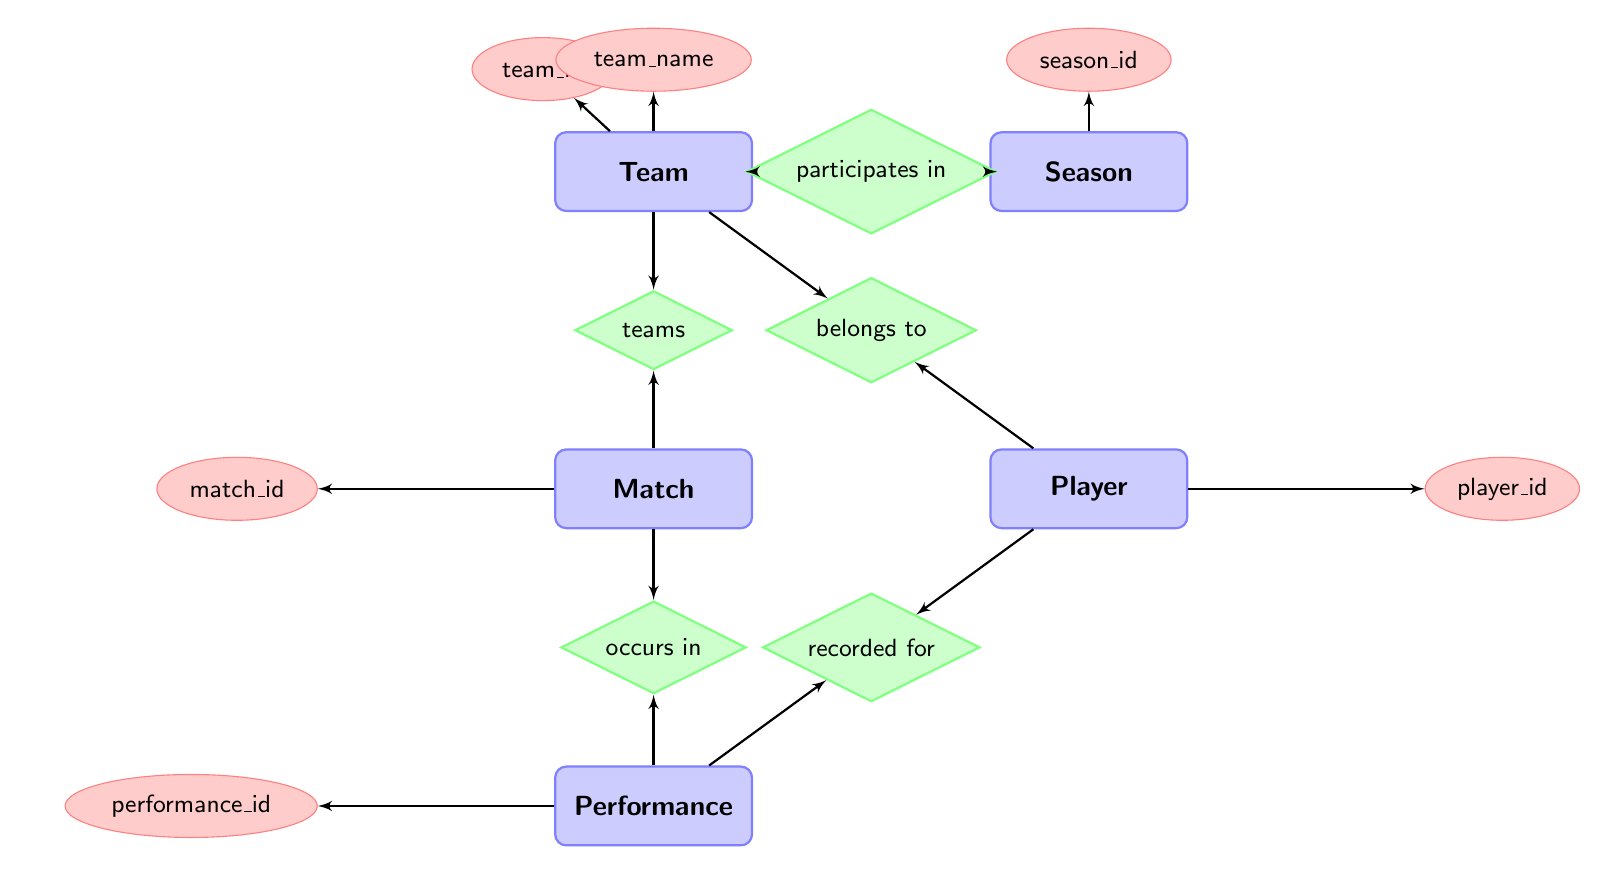What entities are present in the diagram? The diagram consists of five entities: Team, Season, Match, Player, and Performance. These can be identified as the main rectangles in the diagram.
Answer: Team, Season, Match, Player, Performance How many relationships are depicted in the diagram? There are five relationships shown in the diagram, connecting the different entities. Each relationship is represented by a diamond shape.
Answer: Five What is the relationship between Player and Team? The relationship between Player and Team is "belongs to," indicating that each player is associated with a specific team. This can be seen by the connecting line and the diamond labeled "belongs to."
Answer: belongs to Which entity is associated with detailing match performance? The entity that records match performance is Performance. It is linked to both Player and Match, showing its role in detailing how a player performed in a specific match.
Answer: Performance How are the entities Match and Season connected? The connection between Match and Season is indirect through Team. The Team entity participates in the Season, and the Match involves teams; thus, information from these entities can be related through the games played in a given season.
Answer: participates in What attribute describes the identity of a Player? The attribute that uniquely identifies a Player is player_id, which is shown as an oval connected to the Player entity.
Answer: player_id Which teams are involved in a match according to the diagram? A match involves both home and away teams as defined by the relationships under the Match entity. Home and away team IDs connect to the Team entity, indicating their involvement in the match.
Answer: home_team_id, away_team_id How many attributes does the Team entity have? The Team entity has three attributes: team_id, team_name, and location. This is indicated by the ovals connected to the Team rectangle.
Answer: Three Which entity holds the record for individual player's performances in matches? The Performance entity holds the records for individual players' performances in matches. It is associated with both the Player and Match entities, indicating performance metrics for specific games.
Answer: Performance What does the relationship "occurs in" signify in the diagram? The "occurs in" relationship signifies that a recorded performance is linked to a specific match. It connects the Performance entity to the Match entity, showing that performances are based on the matches played.
Answer: occurs in 